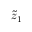Convert formula to latex. <formula><loc_0><loc_0><loc_500><loc_500>\tilde { z } _ { 1 }</formula> 